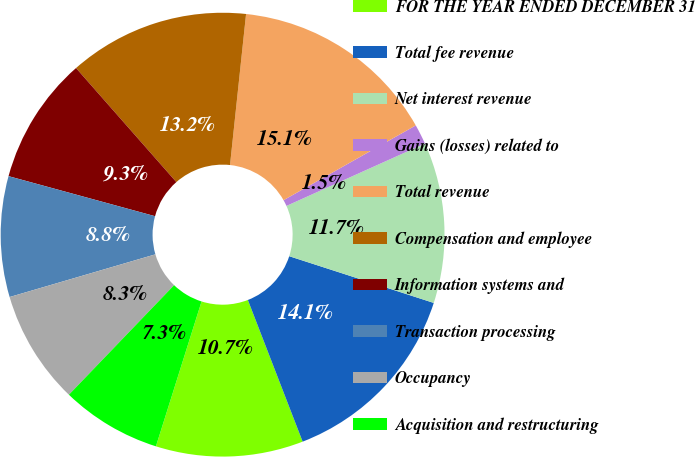Convert chart to OTSL. <chart><loc_0><loc_0><loc_500><loc_500><pie_chart><fcel>FOR THE YEAR ENDED DECEMBER 31<fcel>Total fee revenue<fcel>Net interest revenue<fcel>Gains (losses) related to<fcel>Total revenue<fcel>Compensation and employee<fcel>Information systems and<fcel>Transaction processing<fcel>Occupancy<fcel>Acquisition and restructuring<nl><fcel>10.73%<fcel>14.15%<fcel>11.71%<fcel>1.46%<fcel>15.12%<fcel>13.17%<fcel>9.27%<fcel>8.78%<fcel>8.29%<fcel>7.32%<nl></chart> 